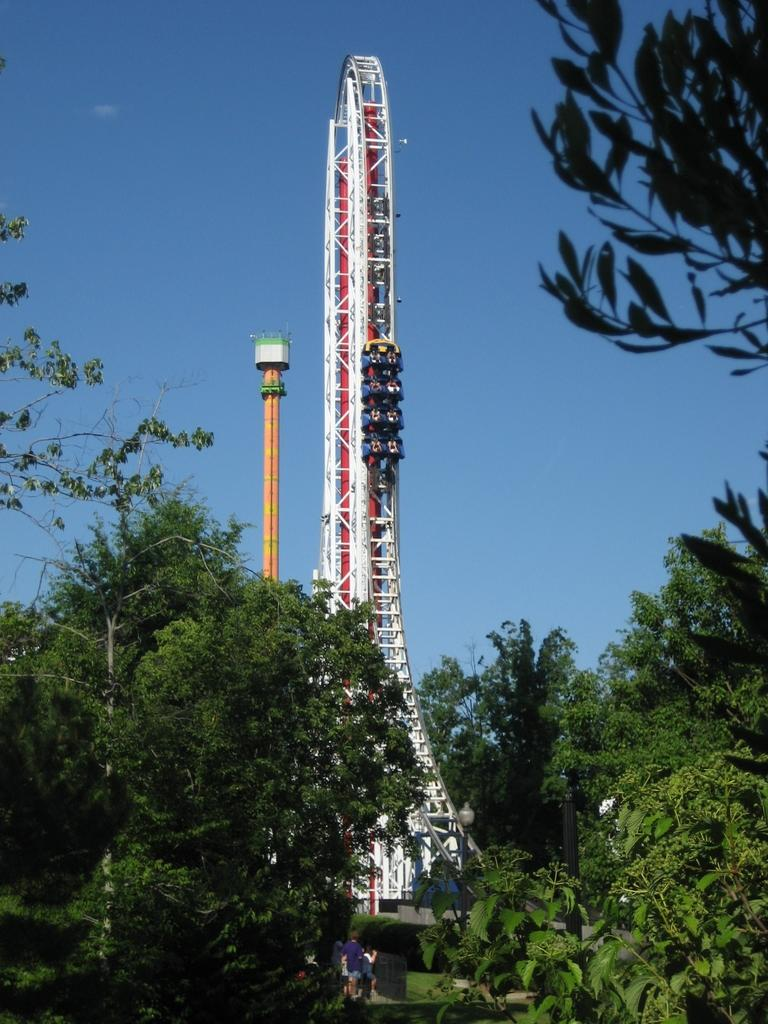What type of vegetation is visible in the front of the image? There are trees in the front of the image. What structure can be seen in the background of the image? There is a tower in the background of the image. What object is present in the image that is typically used for support or signage? There is a pole in the image. Where are the persons located in the image? The persons are in the center of the image. What type of ground cover is visible in the image? There is grass on the ground in the image. Can you see a gate in the wilderness in the image? There is no gate or wilderness present in the image. Is there an airplane flying over the tower in the image? There is no airplane visible in the image. 